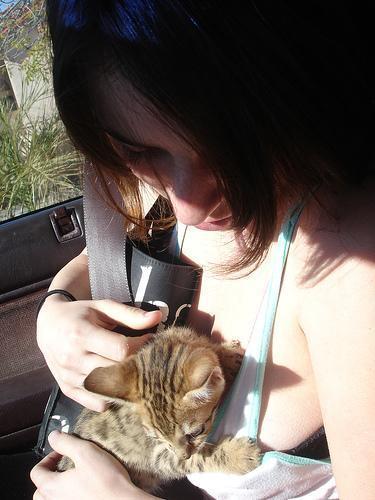How many people are pictured?
Give a very brief answer. 1. 